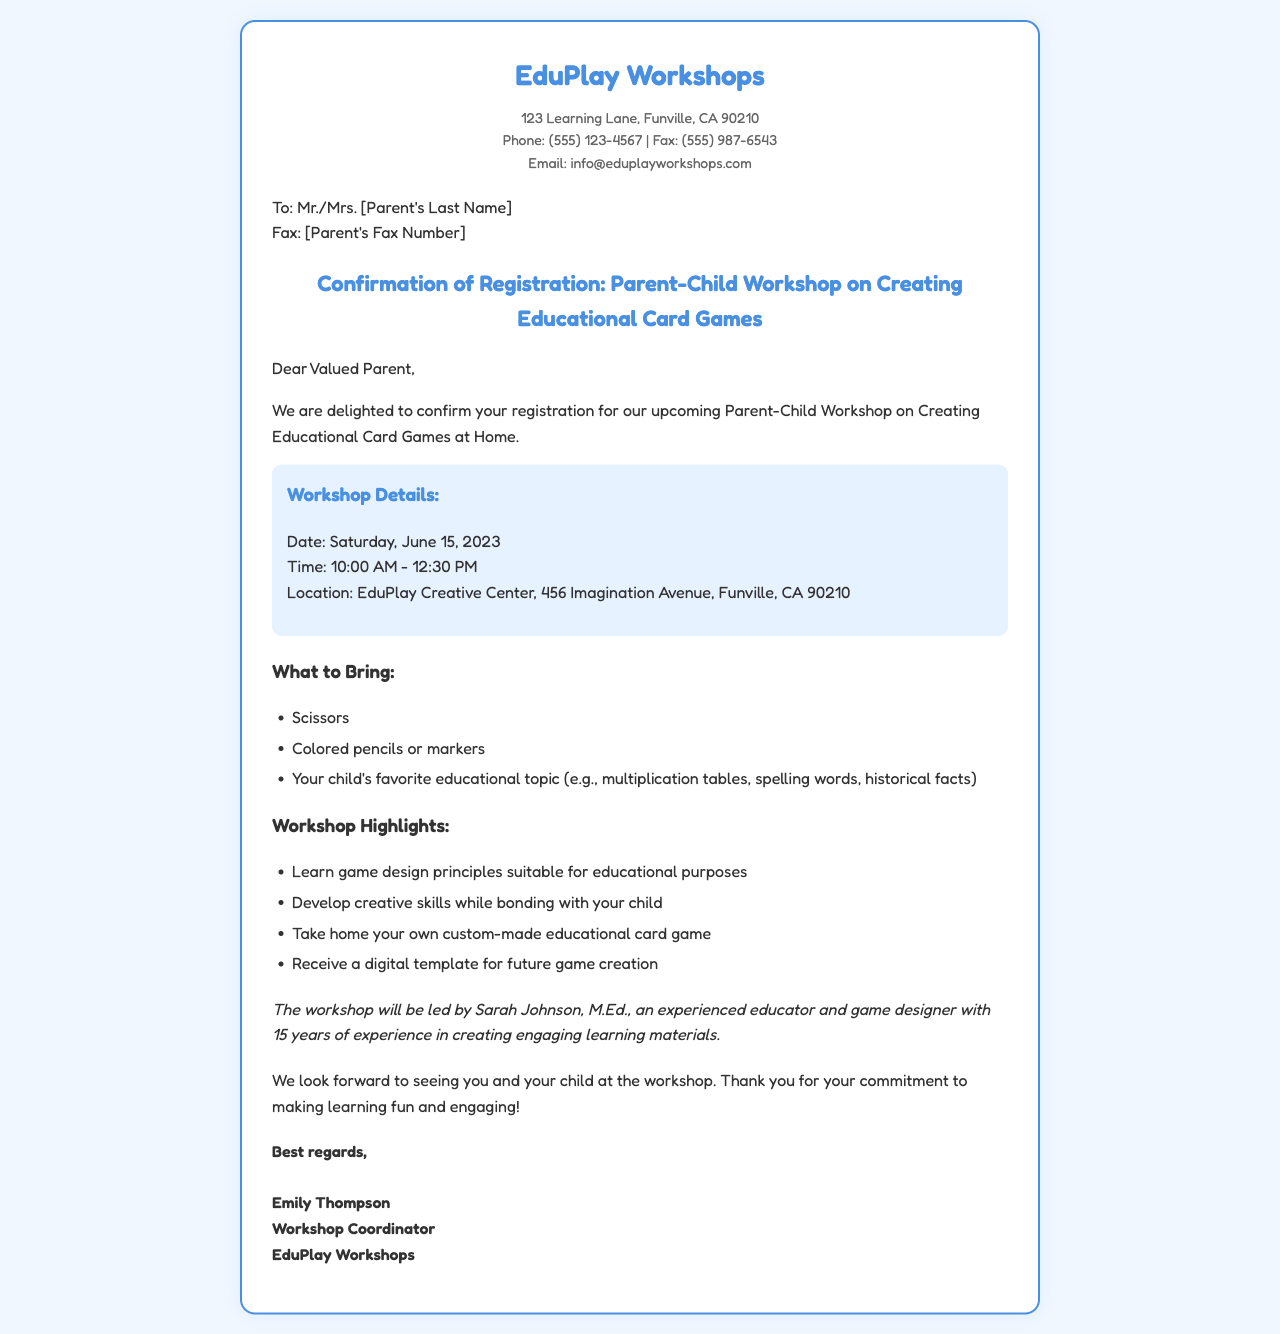What is the date of the workshop? The date is provided in the document under "Workshop Details."
Answer: Saturday, June 15, 2023 What should parents bring to the workshop? The document lists specific items under "What to Bring."
Answer: Scissors, colored pencils or markers, your child's favorite educational topic Who is leading the workshop? The document mentions the facilitator's name at the end of the workshop details.
Answer: Sarah Johnson What is the location of the workshop? The location is specified in the "Workshop Details" section.
Answer: EduPlay Creative Center, 456 Imagination Avenue, Funville, CA 90210 What time does the workshop start? The starting time is mentioned in the "Workshop Details."
Answer: 10:00 AM What will participants take home from the workshop? The document states what participants will receive in the workshop highlights.
Answer: Custom-made educational card game How long is the workshop? The duration can be calculated from the start and end times provided in the document.
Answer: 2.5 hours What is the main focus of the workshop? The document outlines the workshop's purpose in the workshop highlights section.
Answer: Creating educational card games What is the email address for inquiries? The email address is found in the contact information of the document.
Answer: info@eduplayworkshops.com 